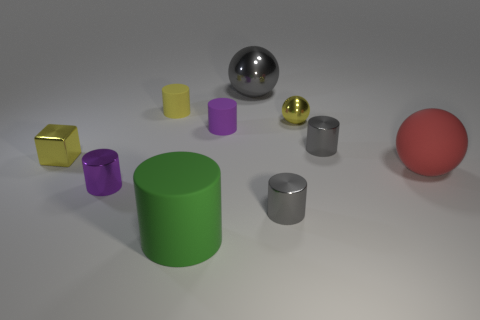Is the color of the tiny metallic block the same as the small sphere?
Make the answer very short. Yes. What number of big gray rubber balls are there?
Provide a succinct answer. 0. What number of balls are either gray metallic objects or yellow things?
Your response must be concise. 2. What number of large objects are left of the rubber thing on the right side of the gray metal sphere?
Keep it short and to the point. 2. Does the small ball have the same material as the big gray ball?
Offer a very short reply. Yes. The sphere that is the same color as the cube is what size?
Offer a very short reply. Small. Are there any small cylinders that have the same material as the large green cylinder?
Provide a short and direct response. Yes. There is a large object right of the tiny gray metallic object that is in front of the big red matte object behind the large matte cylinder; what is its color?
Your answer should be compact. Red. How many brown things are big cylinders or matte objects?
Ensure brevity in your answer.  0. What number of other gray metal things have the same shape as the large metal thing?
Keep it short and to the point. 0. 